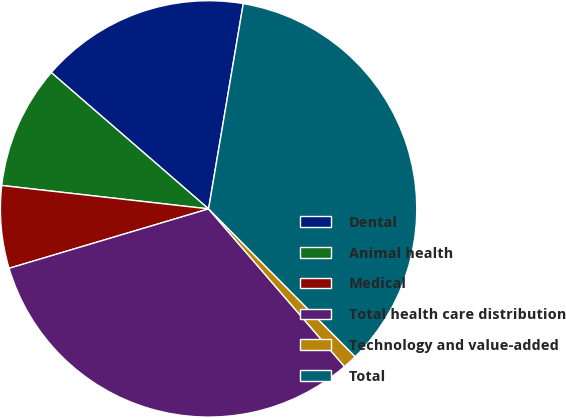<chart> <loc_0><loc_0><loc_500><loc_500><pie_chart><fcel>Dental<fcel>Animal health<fcel>Medical<fcel>Total health care distribution<fcel>Technology and value-added<fcel>Total<nl><fcel>16.3%<fcel>9.57%<fcel>6.4%<fcel>31.72%<fcel>1.11%<fcel>34.9%<nl></chart> 